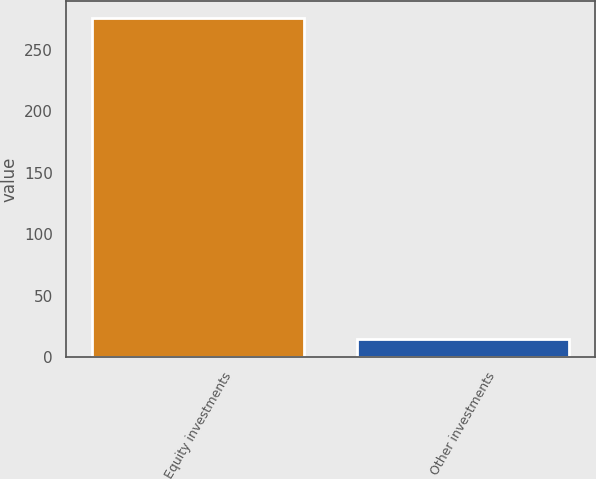Convert chart. <chart><loc_0><loc_0><loc_500><loc_500><bar_chart><fcel>Equity investments<fcel>Other investments<nl><fcel>276<fcel>15<nl></chart> 